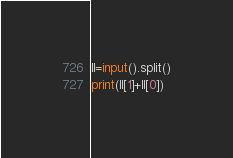Convert code to text. <code><loc_0><loc_0><loc_500><loc_500><_Python_>ll=input().split()
print(ll[1]+ll[0])</code> 